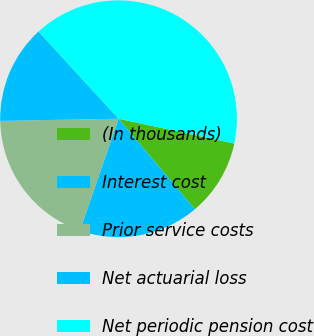Convert chart. <chart><loc_0><loc_0><loc_500><loc_500><pie_chart><fcel>(In thousands)<fcel>Interest cost<fcel>Prior service costs<fcel>Net actuarial loss<fcel>Net periodic pension cost<nl><fcel>10.5%<fcel>16.44%<fcel>19.41%<fcel>13.47%<fcel>40.18%<nl></chart> 